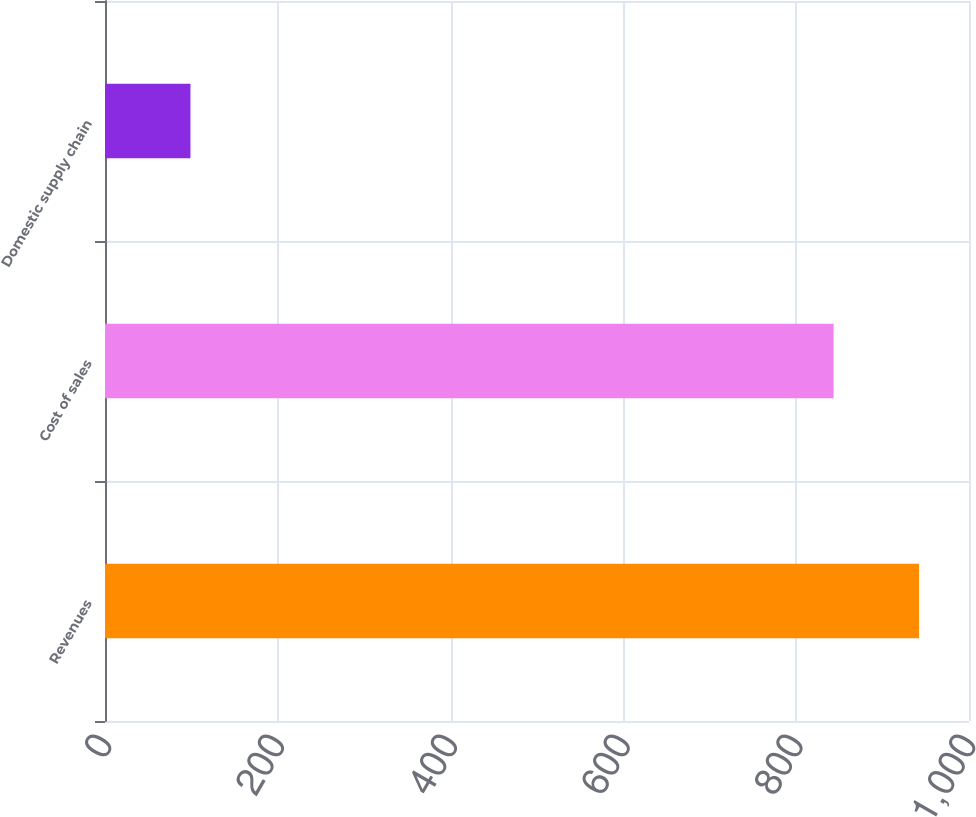Convert chart. <chart><loc_0><loc_0><loc_500><loc_500><bar_chart><fcel>Revenues<fcel>Cost of sales<fcel>Domestic supply chain<nl><fcel>942.2<fcel>843.3<fcel>98.9<nl></chart> 